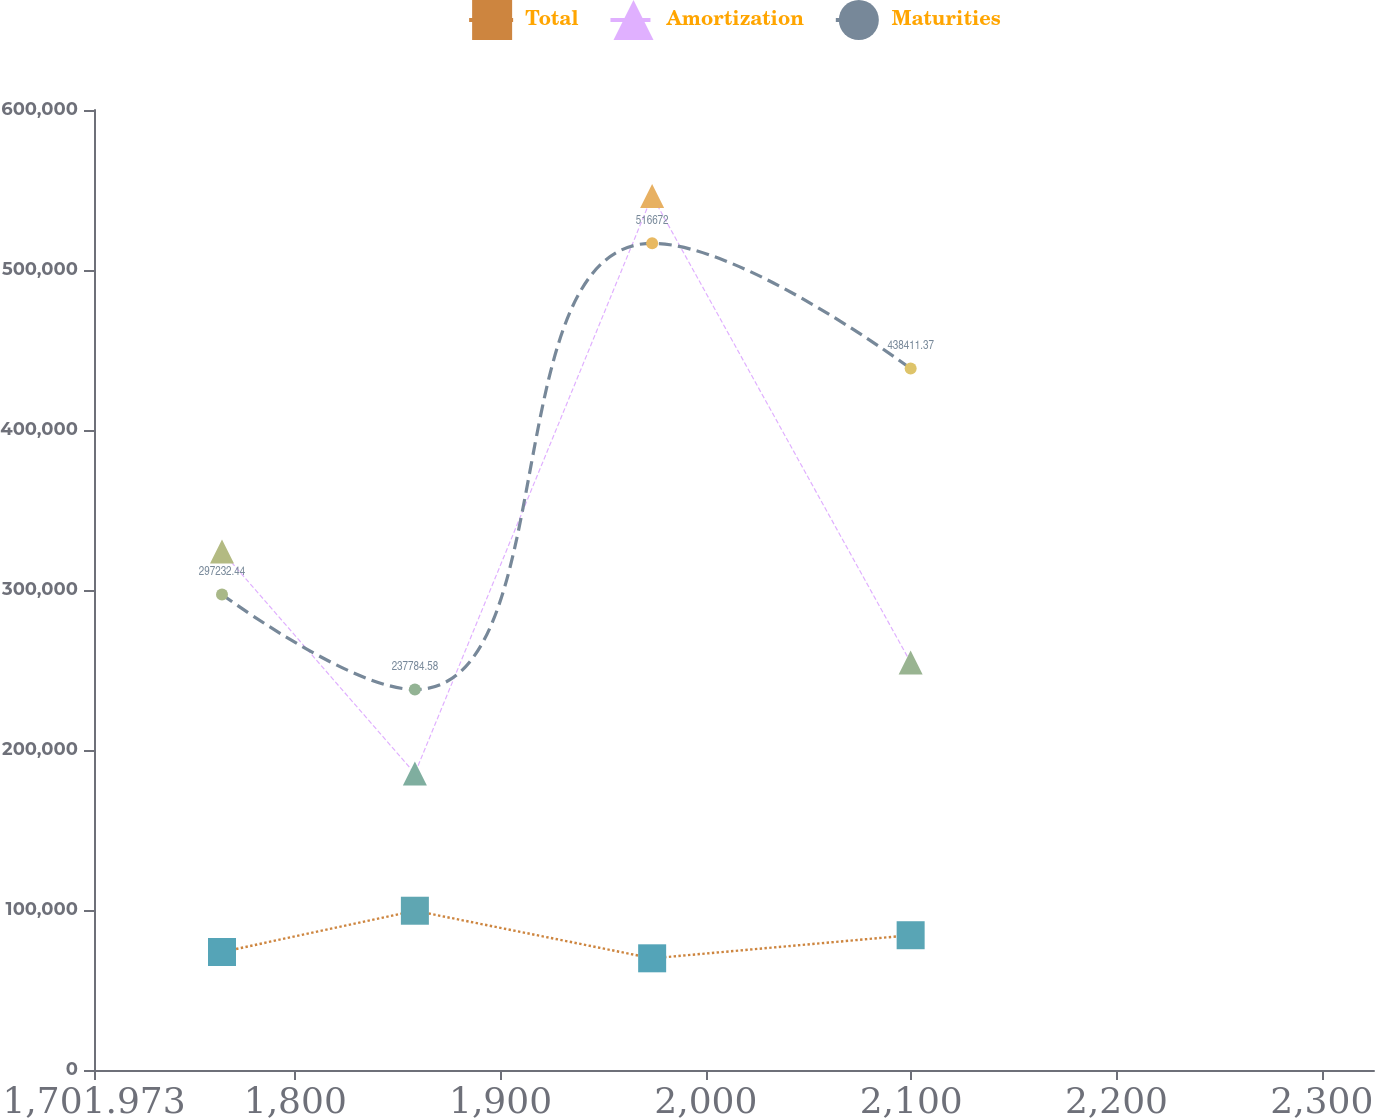<chart> <loc_0><loc_0><loc_500><loc_500><line_chart><ecel><fcel>Total<fcel>Amortization<fcel>Maturities<nl><fcel>1764.32<fcel>73757.3<fcel>324120<fcel>297232<nl><fcel>1858.27<fcel>99542.7<fcel>185344<fcel>237785<nl><fcel>1973.84<fcel>69804.9<fcel>546275<fcel>516672<nl><fcel>2099.75<fcel>84232.3<fcel>254732<fcel>438411<nl><fcel>2387.79<fcel>60019<fcel>879227<fcel>832263<nl></chart> 